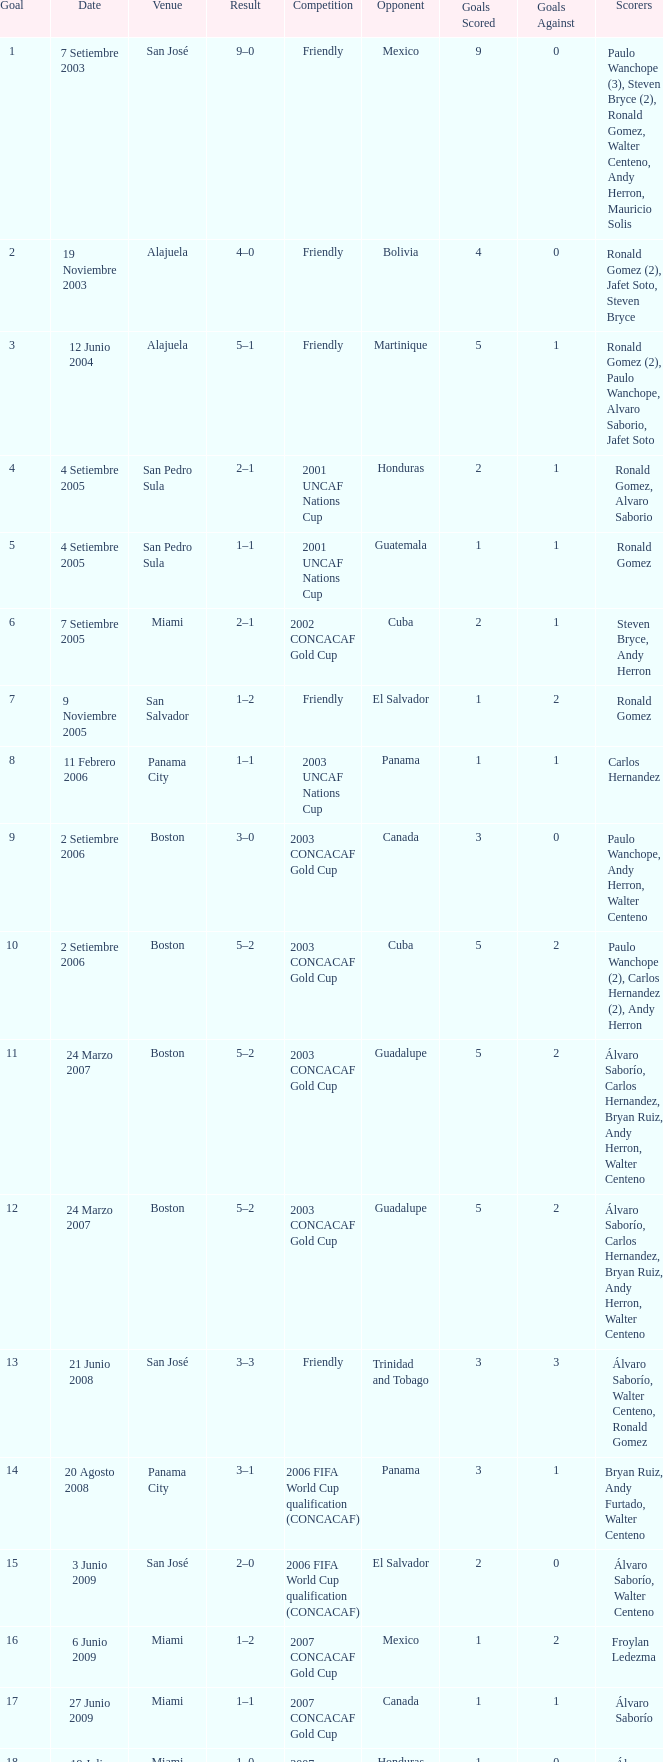How many goals were scored on 21 Junio 2008? 1.0. 